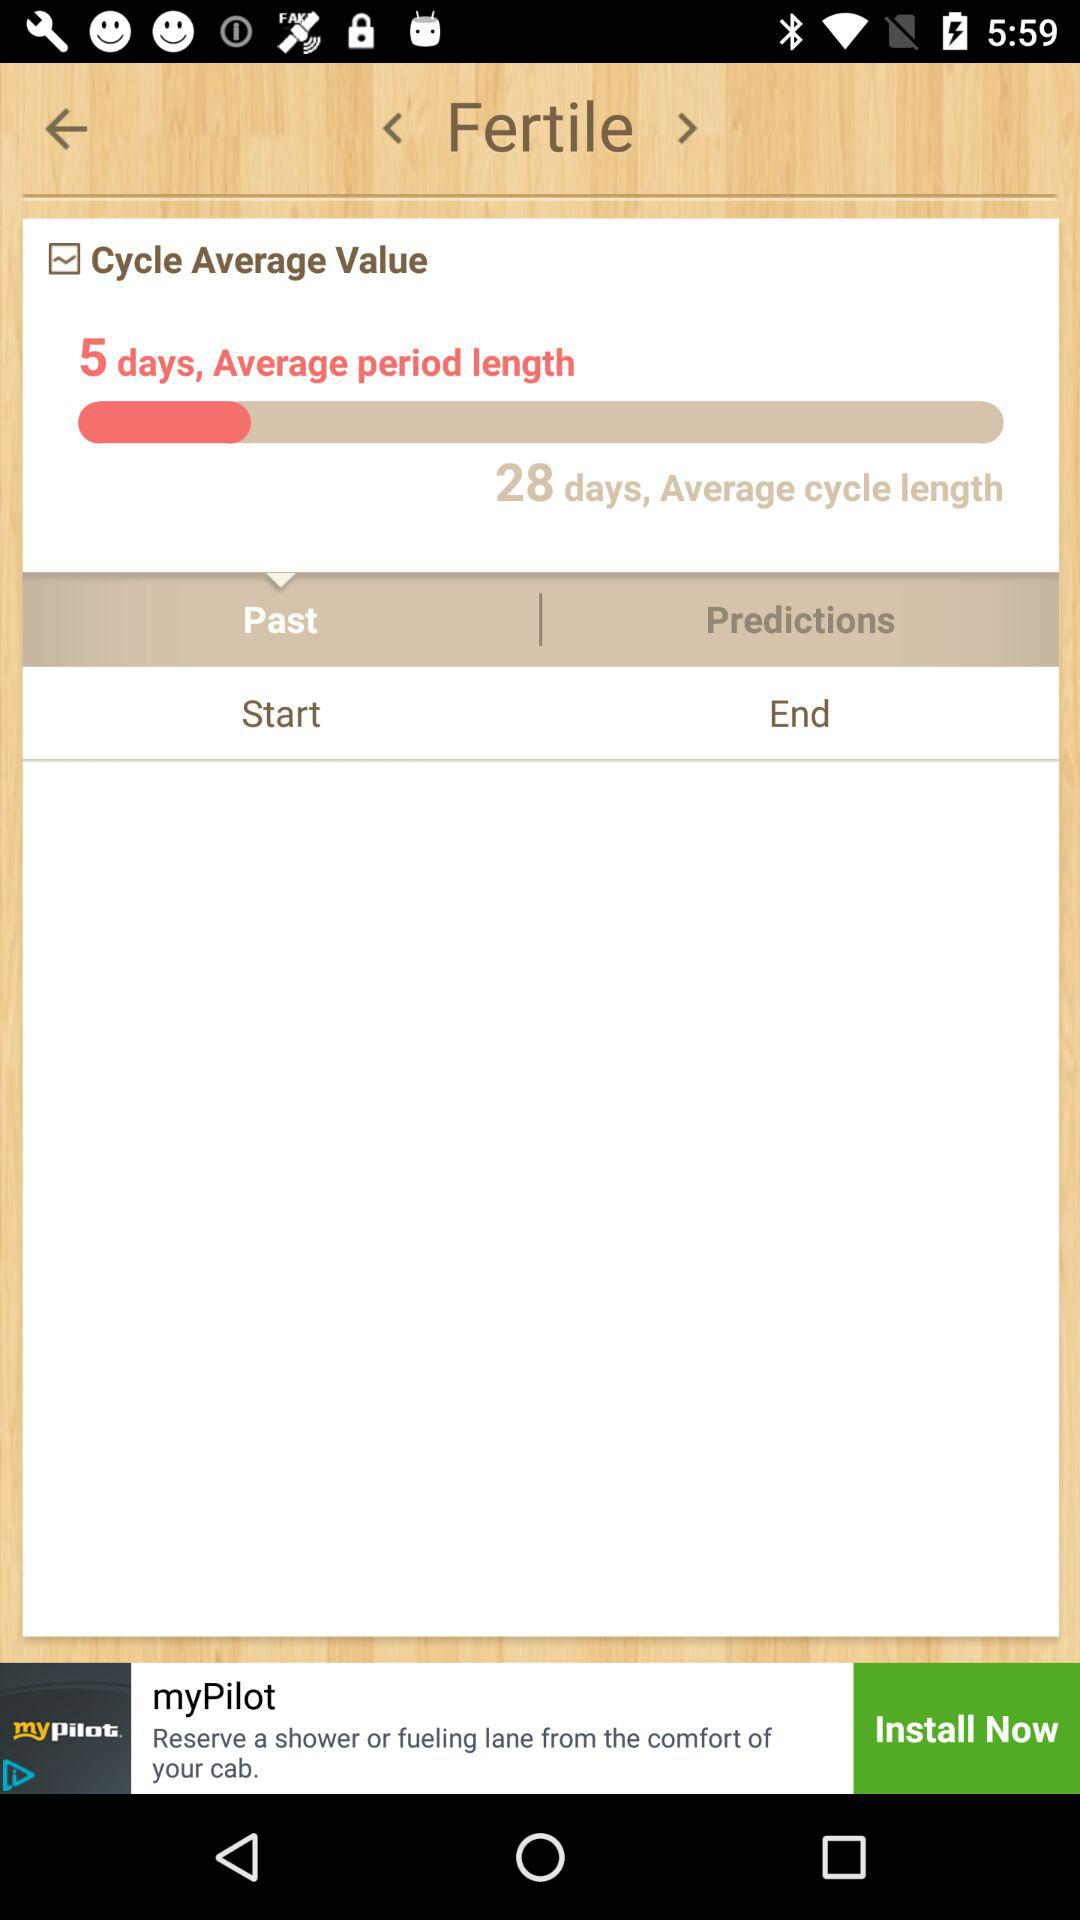How many days longer is the average cycle length than the average period length?
Answer the question using a single word or phrase. 23 